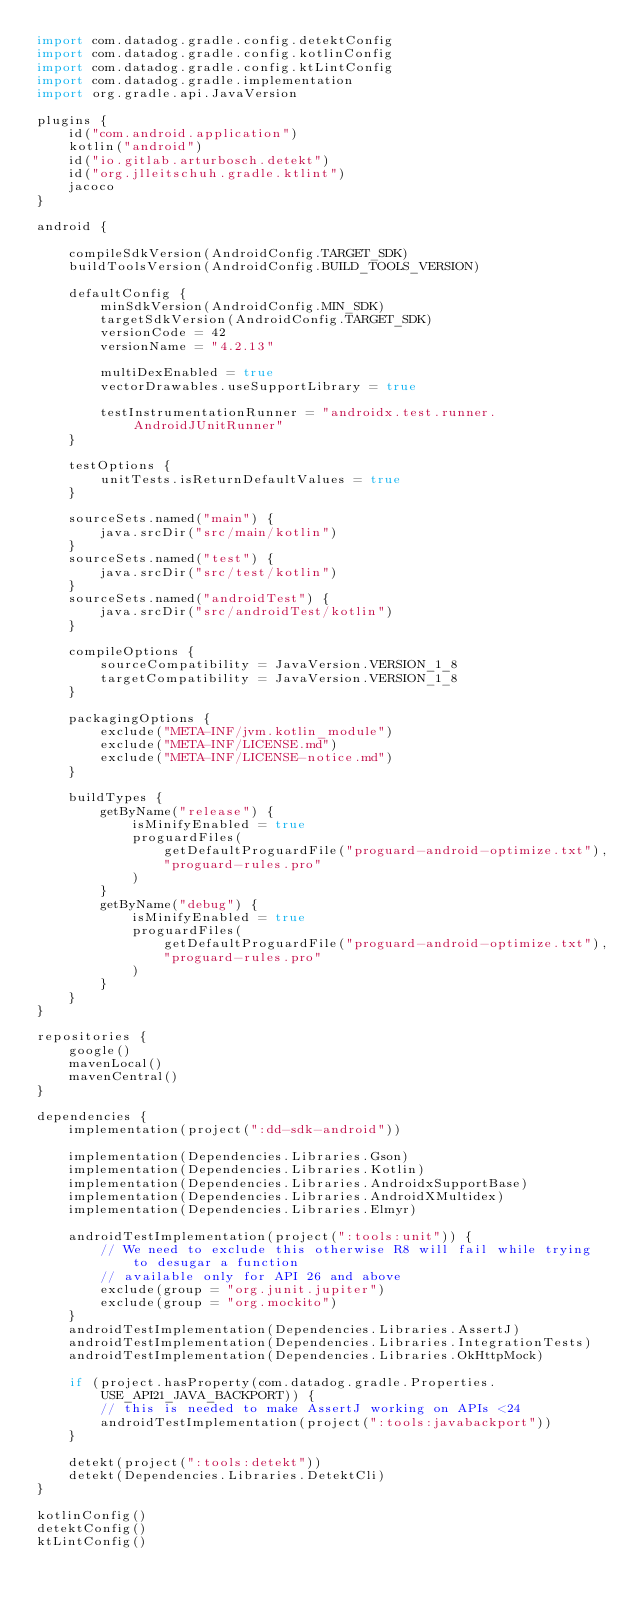<code> <loc_0><loc_0><loc_500><loc_500><_Kotlin_>import com.datadog.gradle.config.detektConfig
import com.datadog.gradle.config.kotlinConfig
import com.datadog.gradle.config.ktLintConfig
import com.datadog.gradle.implementation
import org.gradle.api.JavaVersion

plugins {
    id("com.android.application")
    kotlin("android")
    id("io.gitlab.arturbosch.detekt")
    id("org.jlleitschuh.gradle.ktlint")
    jacoco
}

android {

    compileSdkVersion(AndroidConfig.TARGET_SDK)
    buildToolsVersion(AndroidConfig.BUILD_TOOLS_VERSION)

    defaultConfig {
        minSdkVersion(AndroidConfig.MIN_SDK)
        targetSdkVersion(AndroidConfig.TARGET_SDK)
        versionCode = 42
        versionName = "4.2.13"

        multiDexEnabled = true
        vectorDrawables.useSupportLibrary = true

        testInstrumentationRunner = "androidx.test.runner.AndroidJUnitRunner"
    }

    testOptions {
        unitTests.isReturnDefaultValues = true
    }

    sourceSets.named("main") {
        java.srcDir("src/main/kotlin")
    }
    sourceSets.named("test") {
        java.srcDir("src/test/kotlin")
    }
    sourceSets.named("androidTest") {
        java.srcDir("src/androidTest/kotlin")
    }

    compileOptions {
        sourceCompatibility = JavaVersion.VERSION_1_8
        targetCompatibility = JavaVersion.VERSION_1_8
    }

    packagingOptions {
        exclude("META-INF/jvm.kotlin_module")
        exclude("META-INF/LICENSE.md")
        exclude("META-INF/LICENSE-notice.md")
    }

    buildTypes {
        getByName("release") {
            isMinifyEnabled = true
            proguardFiles(
                getDefaultProguardFile("proguard-android-optimize.txt"),
                "proguard-rules.pro"
            )
        }
        getByName("debug") {
            isMinifyEnabled = true
            proguardFiles(
                getDefaultProguardFile("proguard-android-optimize.txt"),
                "proguard-rules.pro"
            )
        }
    }
}

repositories {
    google()
    mavenLocal()
    mavenCentral()
}

dependencies {
    implementation(project(":dd-sdk-android"))

    implementation(Dependencies.Libraries.Gson)
    implementation(Dependencies.Libraries.Kotlin)
    implementation(Dependencies.Libraries.AndroidxSupportBase)
    implementation(Dependencies.Libraries.AndroidXMultidex)
    implementation(Dependencies.Libraries.Elmyr)

    androidTestImplementation(project(":tools:unit")) {
        // We need to exclude this otherwise R8 will fail while trying to desugar a function
        // available only for API 26 and above
        exclude(group = "org.junit.jupiter")
        exclude(group = "org.mockito")
    }
    androidTestImplementation(Dependencies.Libraries.AssertJ)
    androidTestImplementation(Dependencies.Libraries.IntegrationTests)
    androidTestImplementation(Dependencies.Libraries.OkHttpMock)

    if (project.hasProperty(com.datadog.gradle.Properties.USE_API21_JAVA_BACKPORT)) {
        // this is needed to make AssertJ working on APIs <24
        androidTestImplementation(project(":tools:javabackport"))
    }

    detekt(project(":tools:detekt"))
    detekt(Dependencies.Libraries.DetektCli)
}

kotlinConfig()
detektConfig()
ktLintConfig()
</code> 